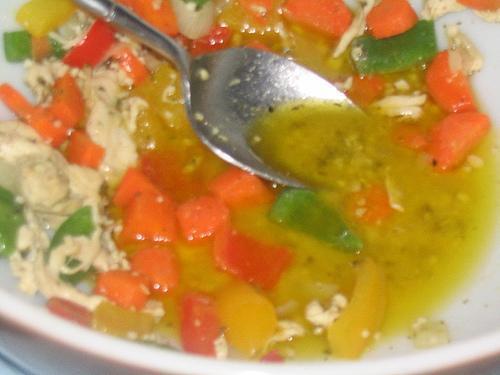How many spoons?
Give a very brief answer. 1. How many carrots are in the picture?
Give a very brief answer. 6. How many bowls can be seen?
Give a very brief answer. 2. 